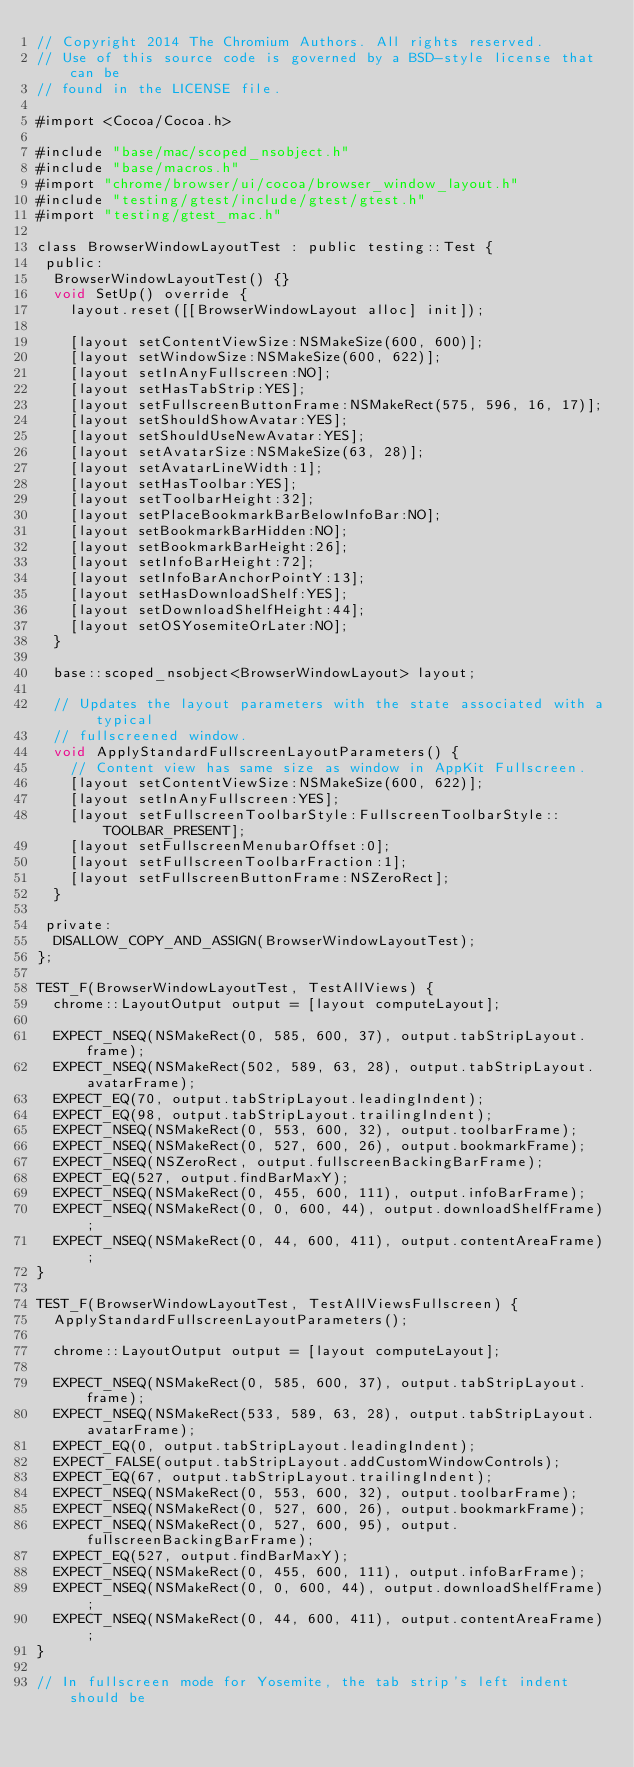Convert code to text. <code><loc_0><loc_0><loc_500><loc_500><_ObjectiveC_>// Copyright 2014 The Chromium Authors. All rights reserved.
// Use of this source code is governed by a BSD-style license that can be
// found in the LICENSE file.

#import <Cocoa/Cocoa.h>

#include "base/mac/scoped_nsobject.h"
#include "base/macros.h"
#import "chrome/browser/ui/cocoa/browser_window_layout.h"
#include "testing/gtest/include/gtest/gtest.h"
#import "testing/gtest_mac.h"

class BrowserWindowLayoutTest : public testing::Test {
 public:
  BrowserWindowLayoutTest() {}
  void SetUp() override {
    layout.reset([[BrowserWindowLayout alloc] init]);

    [layout setContentViewSize:NSMakeSize(600, 600)];
    [layout setWindowSize:NSMakeSize(600, 622)];
    [layout setInAnyFullscreen:NO];
    [layout setHasTabStrip:YES];
    [layout setFullscreenButtonFrame:NSMakeRect(575, 596, 16, 17)];
    [layout setShouldShowAvatar:YES];
    [layout setShouldUseNewAvatar:YES];
    [layout setAvatarSize:NSMakeSize(63, 28)];
    [layout setAvatarLineWidth:1];
    [layout setHasToolbar:YES];
    [layout setToolbarHeight:32];
    [layout setPlaceBookmarkBarBelowInfoBar:NO];
    [layout setBookmarkBarHidden:NO];
    [layout setBookmarkBarHeight:26];
    [layout setInfoBarHeight:72];
    [layout setInfoBarAnchorPointY:13];
    [layout setHasDownloadShelf:YES];
    [layout setDownloadShelfHeight:44];
    [layout setOSYosemiteOrLater:NO];
  }

  base::scoped_nsobject<BrowserWindowLayout> layout;

  // Updates the layout parameters with the state associated with a typical
  // fullscreened window.
  void ApplyStandardFullscreenLayoutParameters() {
    // Content view has same size as window in AppKit Fullscreen.
    [layout setContentViewSize:NSMakeSize(600, 622)];
    [layout setInAnyFullscreen:YES];
    [layout setFullscreenToolbarStyle:FullscreenToolbarStyle::TOOLBAR_PRESENT];
    [layout setFullscreenMenubarOffset:0];
    [layout setFullscreenToolbarFraction:1];
    [layout setFullscreenButtonFrame:NSZeroRect];
  }

 private:
  DISALLOW_COPY_AND_ASSIGN(BrowserWindowLayoutTest);
};

TEST_F(BrowserWindowLayoutTest, TestAllViews) {
  chrome::LayoutOutput output = [layout computeLayout];

  EXPECT_NSEQ(NSMakeRect(0, 585, 600, 37), output.tabStripLayout.frame);
  EXPECT_NSEQ(NSMakeRect(502, 589, 63, 28), output.tabStripLayout.avatarFrame);
  EXPECT_EQ(70, output.tabStripLayout.leadingIndent);
  EXPECT_EQ(98, output.tabStripLayout.trailingIndent);
  EXPECT_NSEQ(NSMakeRect(0, 553, 600, 32), output.toolbarFrame);
  EXPECT_NSEQ(NSMakeRect(0, 527, 600, 26), output.bookmarkFrame);
  EXPECT_NSEQ(NSZeroRect, output.fullscreenBackingBarFrame);
  EXPECT_EQ(527, output.findBarMaxY);
  EXPECT_NSEQ(NSMakeRect(0, 455, 600, 111), output.infoBarFrame);
  EXPECT_NSEQ(NSMakeRect(0, 0, 600, 44), output.downloadShelfFrame);
  EXPECT_NSEQ(NSMakeRect(0, 44, 600, 411), output.contentAreaFrame);
}

TEST_F(BrowserWindowLayoutTest, TestAllViewsFullscreen) {
  ApplyStandardFullscreenLayoutParameters();

  chrome::LayoutOutput output = [layout computeLayout];

  EXPECT_NSEQ(NSMakeRect(0, 585, 600, 37), output.tabStripLayout.frame);
  EXPECT_NSEQ(NSMakeRect(533, 589, 63, 28), output.tabStripLayout.avatarFrame);
  EXPECT_EQ(0, output.tabStripLayout.leadingIndent);
  EXPECT_FALSE(output.tabStripLayout.addCustomWindowControls);
  EXPECT_EQ(67, output.tabStripLayout.trailingIndent);
  EXPECT_NSEQ(NSMakeRect(0, 553, 600, 32), output.toolbarFrame);
  EXPECT_NSEQ(NSMakeRect(0, 527, 600, 26), output.bookmarkFrame);
  EXPECT_NSEQ(NSMakeRect(0, 527, 600, 95), output.fullscreenBackingBarFrame);
  EXPECT_EQ(527, output.findBarMaxY);
  EXPECT_NSEQ(NSMakeRect(0, 455, 600, 111), output.infoBarFrame);
  EXPECT_NSEQ(NSMakeRect(0, 0, 600, 44), output.downloadShelfFrame);
  EXPECT_NSEQ(NSMakeRect(0, 44, 600, 411), output.contentAreaFrame);
}

// In fullscreen mode for Yosemite, the tab strip's left indent should be</code> 